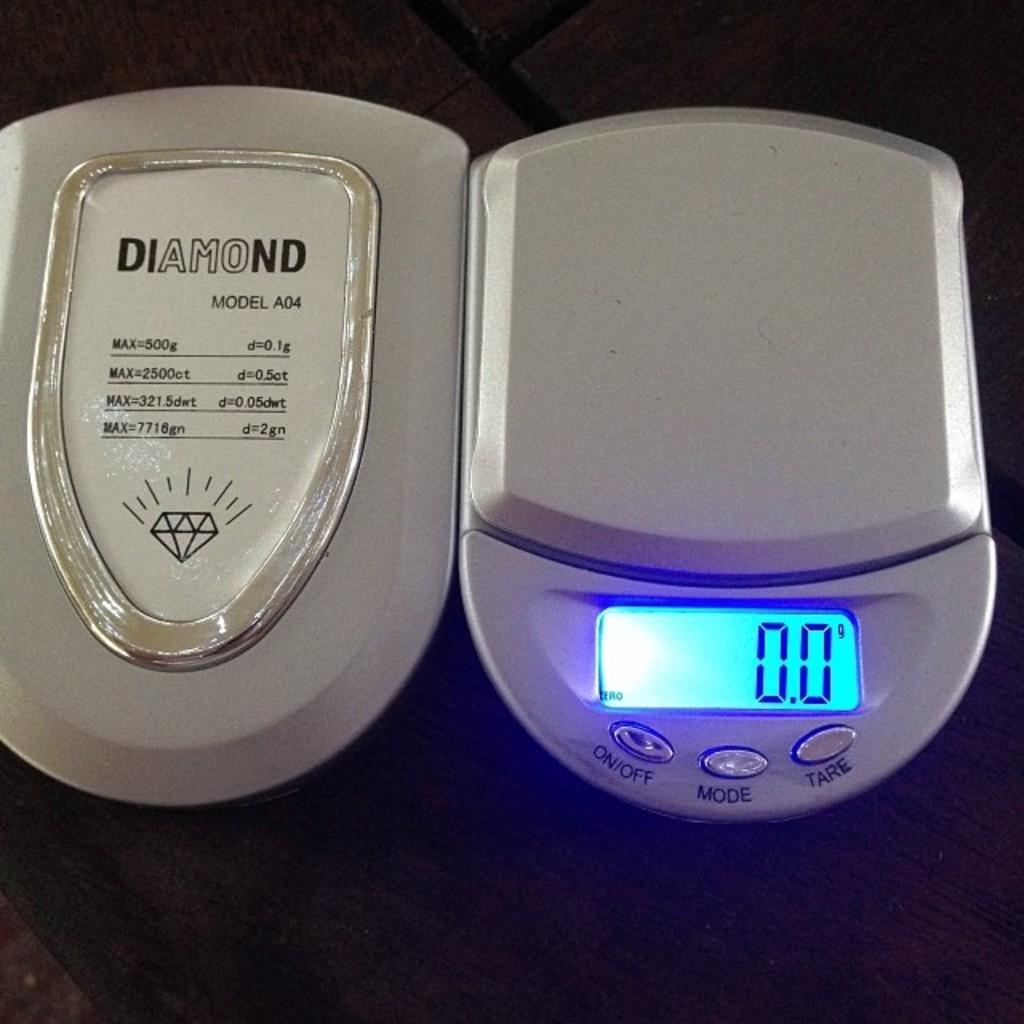<image>
Summarize the visual content of the image. A Diamond brand scale with a digital display lit up. 